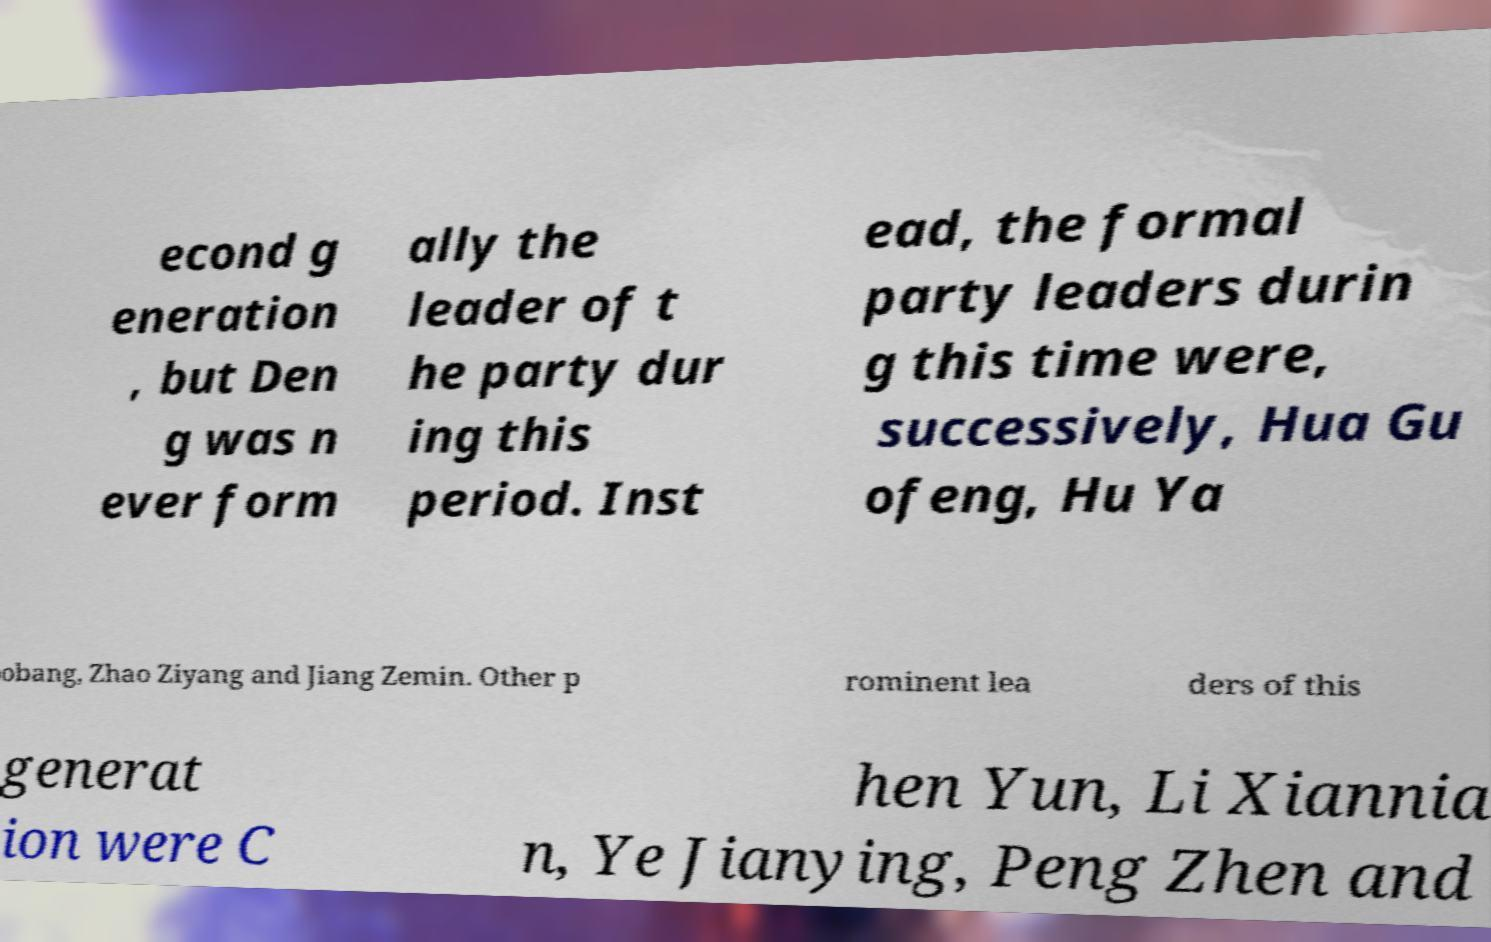Can you read and provide the text displayed in the image?This photo seems to have some interesting text. Can you extract and type it out for me? econd g eneration , but Den g was n ever form ally the leader of t he party dur ing this period. Inst ead, the formal party leaders durin g this time were, successively, Hua Gu ofeng, Hu Ya obang, Zhao Ziyang and Jiang Zemin. Other p rominent lea ders of this generat ion were C hen Yun, Li Xiannia n, Ye Jianying, Peng Zhen and 